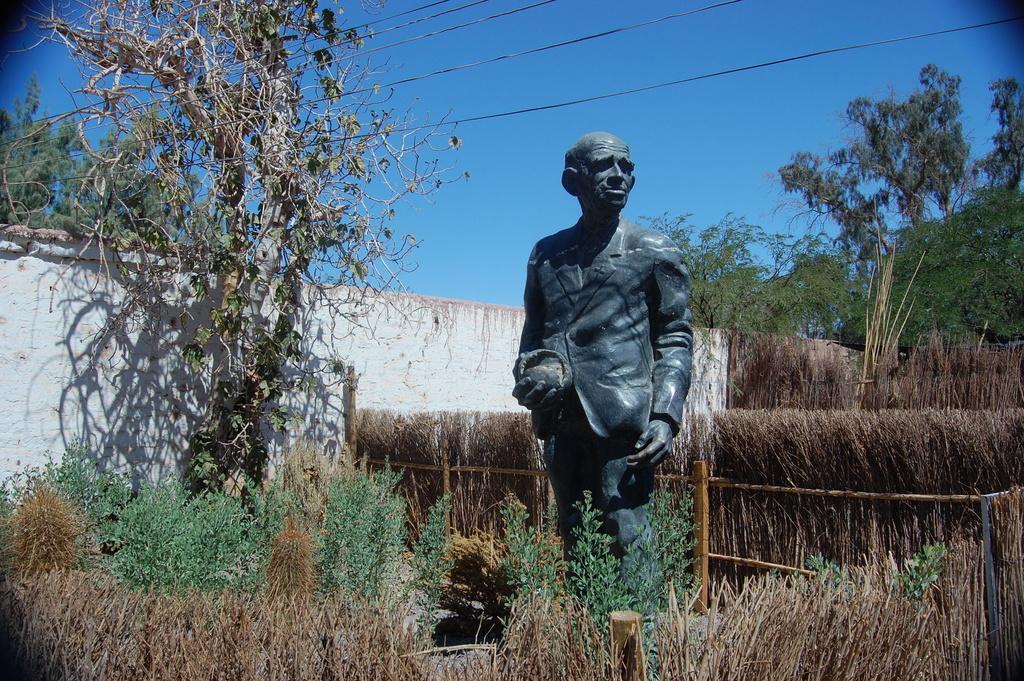Describe this image in one or two sentences. In this picture we see a statue placed in between a field surrounded by bushes and trees. Here the sky is blue. 